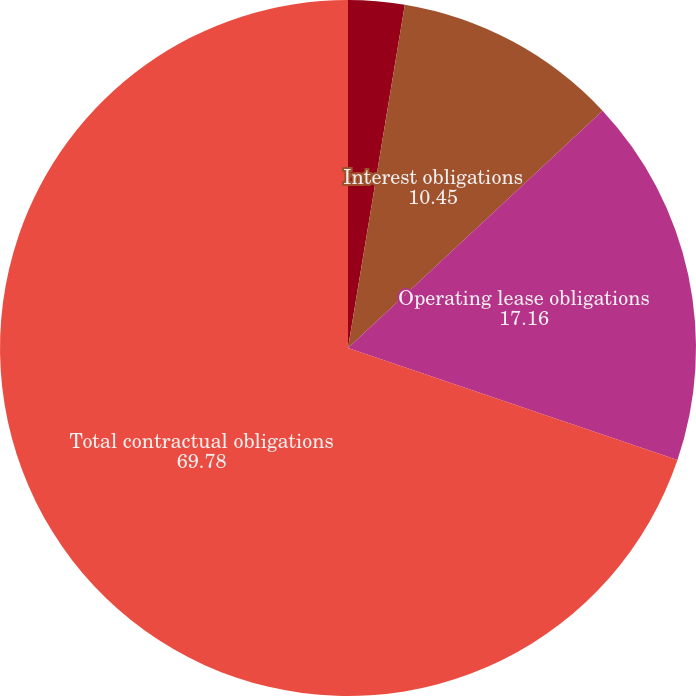<chart> <loc_0><loc_0><loc_500><loc_500><pie_chart><fcel>Long-term borrowings<fcel>Interest obligations<fcel>Operating lease obligations<fcel>Total contractual obligations<nl><fcel>2.61%<fcel>10.45%<fcel>17.16%<fcel>69.78%<nl></chart> 